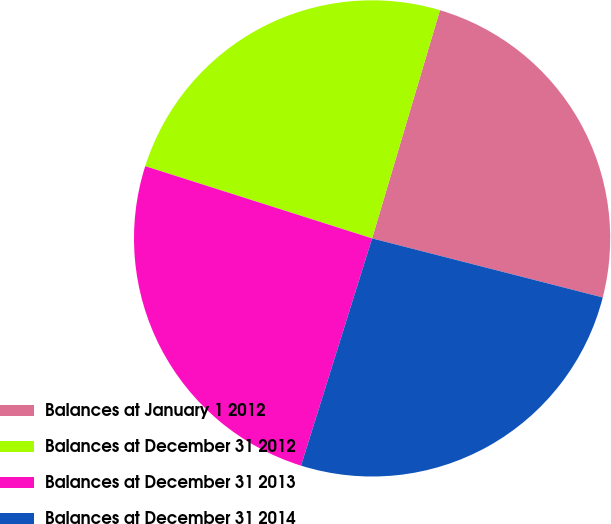Convert chart to OTSL. <chart><loc_0><loc_0><loc_500><loc_500><pie_chart><fcel>Balances at January 1 2012<fcel>Balances at December 31 2012<fcel>Balances at December 31 2013<fcel>Balances at December 31 2014<nl><fcel>24.39%<fcel>24.69%<fcel>25.08%<fcel>25.83%<nl></chart> 